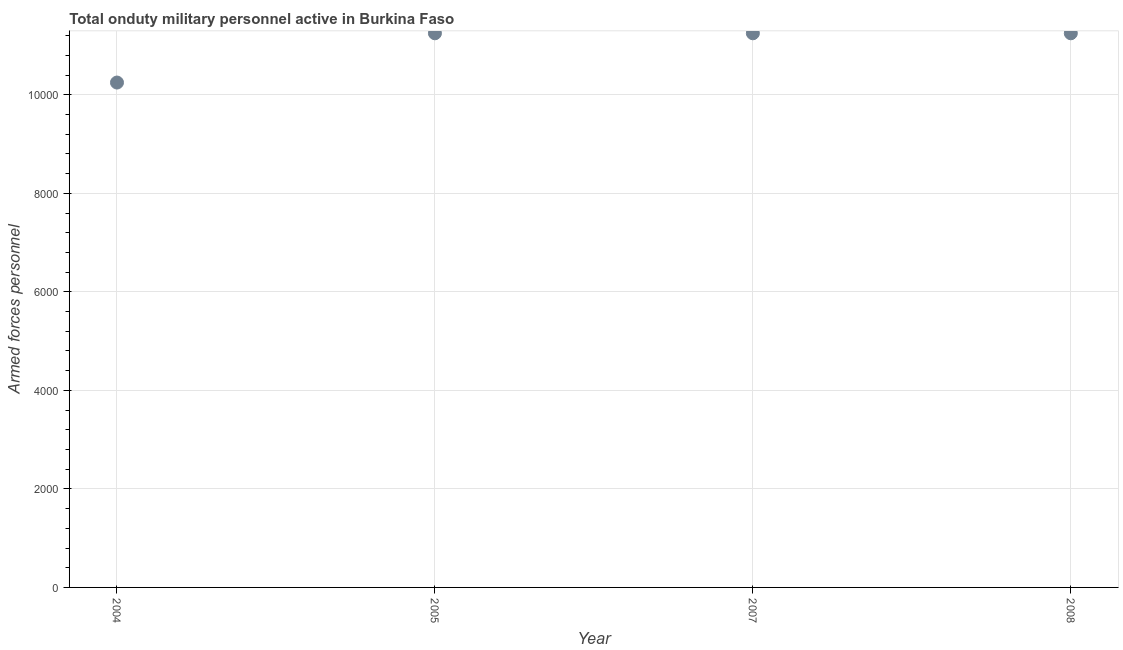What is the number of armed forces personnel in 2007?
Keep it short and to the point. 1.12e+04. Across all years, what is the maximum number of armed forces personnel?
Your answer should be compact. 1.12e+04. Across all years, what is the minimum number of armed forces personnel?
Offer a very short reply. 1.02e+04. What is the sum of the number of armed forces personnel?
Provide a succinct answer. 4.40e+04. What is the difference between the number of armed forces personnel in 2004 and 2007?
Keep it short and to the point. -1000. What is the average number of armed forces personnel per year?
Make the answer very short. 1.10e+04. What is the median number of armed forces personnel?
Your response must be concise. 1.12e+04. In how many years, is the number of armed forces personnel greater than 10000 ?
Offer a terse response. 4. Do a majority of the years between 2007 and 2008 (inclusive) have number of armed forces personnel greater than 7200 ?
Offer a very short reply. Yes. What is the ratio of the number of armed forces personnel in 2005 to that in 2007?
Your answer should be compact. 1. What is the difference between the highest and the lowest number of armed forces personnel?
Your response must be concise. 1000. Does the number of armed forces personnel monotonically increase over the years?
Your answer should be compact. No. How many dotlines are there?
Offer a terse response. 1. What is the difference between two consecutive major ticks on the Y-axis?
Your answer should be compact. 2000. Are the values on the major ticks of Y-axis written in scientific E-notation?
Give a very brief answer. No. Does the graph contain grids?
Offer a very short reply. Yes. What is the title of the graph?
Your answer should be very brief. Total onduty military personnel active in Burkina Faso. What is the label or title of the Y-axis?
Provide a succinct answer. Armed forces personnel. What is the Armed forces personnel in 2004?
Your answer should be very brief. 1.02e+04. What is the Armed forces personnel in 2005?
Offer a terse response. 1.12e+04. What is the Armed forces personnel in 2007?
Provide a succinct answer. 1.12e+04. What is the Armed forces personnel in 2008?
Offer a very short reply. 1.12e+04. What is the difference between the Armed forces personnel in 2004 and 2005?
Give a very brief answer. -1000. What is the difference between the Armed forces personnel in 2004 and 2007?
Give a very brief answer. -1000. What is the difference between the Armed forces personnel in 2004 and 2008?
Make the answer very short. -1000. What is the difference between the Armed forces personnel in 2005 and 2008?
Provide a succinct answer. 0. What is the difference between the Armed forces personnel in 2007 and 2008?
Keep it short and to the point. 0. What is the ratio of the Armed forces personnel in 2004 to that in 2005?
Keep it short and to the point. 0.91. What is the ratio of the Armed forces personnel in 2004 to that in 2007?
Make the answer very short. 0.91. What is the ratio of the Armed forces personnel in 2004 to that in 2008?
Your answer should be compact. 0.91. What is the ratio of the Armed forces personnel in 2005 to that in 2007?
Make the answer very short. 1. What is the ratio of the Armed forces personnel in 2005 to that in 2008?
Provide a succinct answer. 1. 